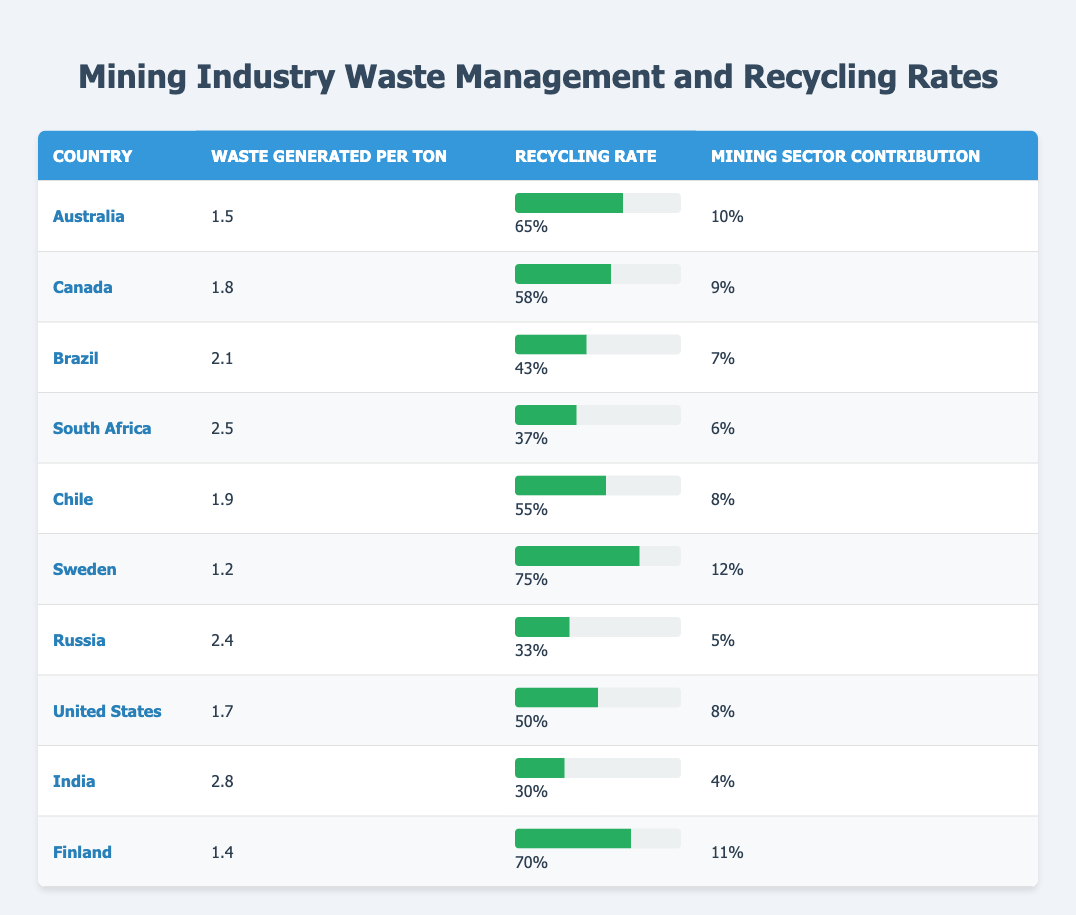What is the recycling rate for Sweden? The recycling rate for Sweden is listed in the table under the Recycling Rate column corresponding to Sweden. It shows 0.75, which can be expressed as 75% when converted.
Answer: 75% Which country produces the most waste per ton? To find the country with the most waste generated per ton, I check the Waste Generated Per Ton column and look for the highest value. India has the highest value at 2.8 tons.
Answer: India What is the average recycling rate for the top three countries by recycling rates? The top three countries by recycling rates are Sweden (0.75), Australia (0.65), and Finland (0.70). The sum of their recycling rates is 0.75 + 0.65 + 0.70 = 2.10. To find the average, divide by 3, resulting in 2.10 / 3 = 0.70, or 70%.
Answer: 70% Is the mining sector contribution higher for Canada or Australia? I compare the Mining Sector Contribution values for Canada (0.09) and Australia (0.10) as listed in the table. Since 0.10 is greater than 0.09, Australia has the higher contribution.
Answer: Australia What is the difference in waste generated per ton between Brazil and South Africa? I find the waste generated per ton for Brazil (2.1) and South Africa (2.5). The difference is calculated as 2.5 - 2.1 = 0.4 tons, meaning South Africa generates 0.4 tons more waste per ton than Brazil.
Answer: 0.4 tons Does any country have a recycling rate lower than 35%? I check the Recycling Rate column for any values below 0.35 (or 35%). Brazil (0.43), South Africa (0.37), Russia (0.33), and India (0.30) all show recycling rates below this percentage, confirming that several countries have rates below 35%.
Answer: Yes Which country has the highest contribution from the mining sector? The Mining Sector Contribution values are compared; Sweden has the highest value of 0.12 compared to others, showing that Sweden has the highest sector contribution.
Answer: Sweden What is the average waste generated per ton for all countries listed? First, I sum the Waste Generated Per Ton values: 1.5 + 1.8 + 2.1 + 2.5 + 1.9 + 1.2 + 2.4 + 1.7 + 2.8 + 1.4 = 19.1. There are 10 countries, so I divide the sum by 10 to get the average: 19.1 / 10 = 1.91 tons per ton.
Answer: 1.91 tons per ton 